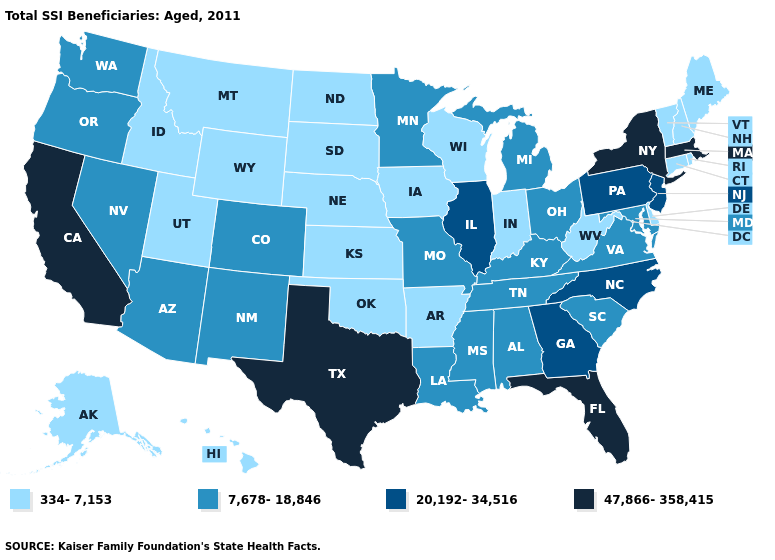Among the states that border New Jersey , which have the highest value?
Give a very brief answer. New York. Among the states that border Washington , which have the highest value?
Quick response, please. Oregon. Is the legend a continuous bar?
Short answer required. No. What is the value of Alaska?
Quick response, please. 334-7,153. Name the states that have a value in the range 47,866-358,415?
Give a very brief answer. California, Florida, Massachusetts, New York, Texas. Does Arkansas have the lowest value in the USA?
Short answer required. Yes. Name the states that have a value in the range 20,192-34,516?
Quick response, please. Georgia, Illinois, New Jersey, North Carolina, Pennsylvania. Name the states that have a value in the range 7,678-18,846?
Write a very short answer. Alabama, Arizona, Colorado, Kentucky, Louisiana, Maryland, Michigan, Minnesota, Mississippi, Missouri, Nevada, New Mexico, Ohio, Oregon, South Carolina, Tennessee, Virginia, Washington. Does the first symbol in the legend represent the smallest category?
Short answer required. Yes. Which states have the lowest value in the USA?
Short answer required. Alaska, Arkansas, Connecticut, Delaware, Hawaii, Idaho, Indiana, Iowa, Kansas, Maine, Montana, Nebraska, New Hampshire, North Dakota, Oklahoma, Rhode Island, South Dakota, Utah, Vermont, West Virginia, Wisconsin, Wyoming. Among the states that border Connecticut , which have the highest value?
Keep it brief. Massachusetts, New York. Name the states that have a value in the range 20,192-34,516?
Write a very short answer. Georgia, Illinois, New Jersey, North Carolina, Pennsylvania. What is the value of Connecticut?
Quick response, please. 334-7,153. Name the states that have a value in the range 47,866-358,415?
Write a very short answer. California, Florida, Massachusetts, New York, Texas. What is the value of Oregon?
Answer briefly. 7,678-18,846. 